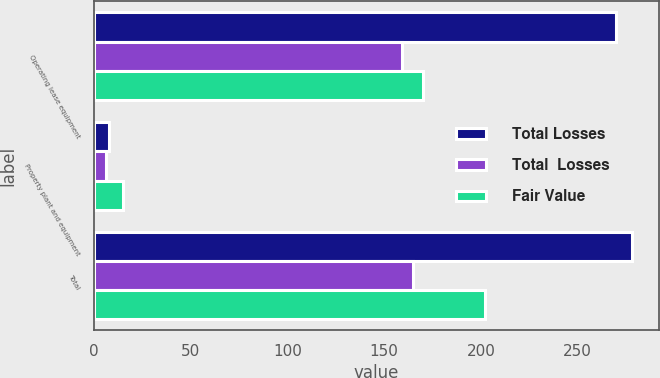<chart> <loc_0><loc_0><loc_500><loc_500><stacked_bar_chart><ecel><fcel>Operating lease equipment<fcel>Property plant and equipment<fcel>Total<nl><fcel>Total Losses<fcel>270<fcel>8<fcel>278<nl><fcel>Total  Losses<fcel>159<fcel>6<fcel>165<nl><fcel>Fair Value<fcel>170<fcel>15<fcel>202<nl></chart> 